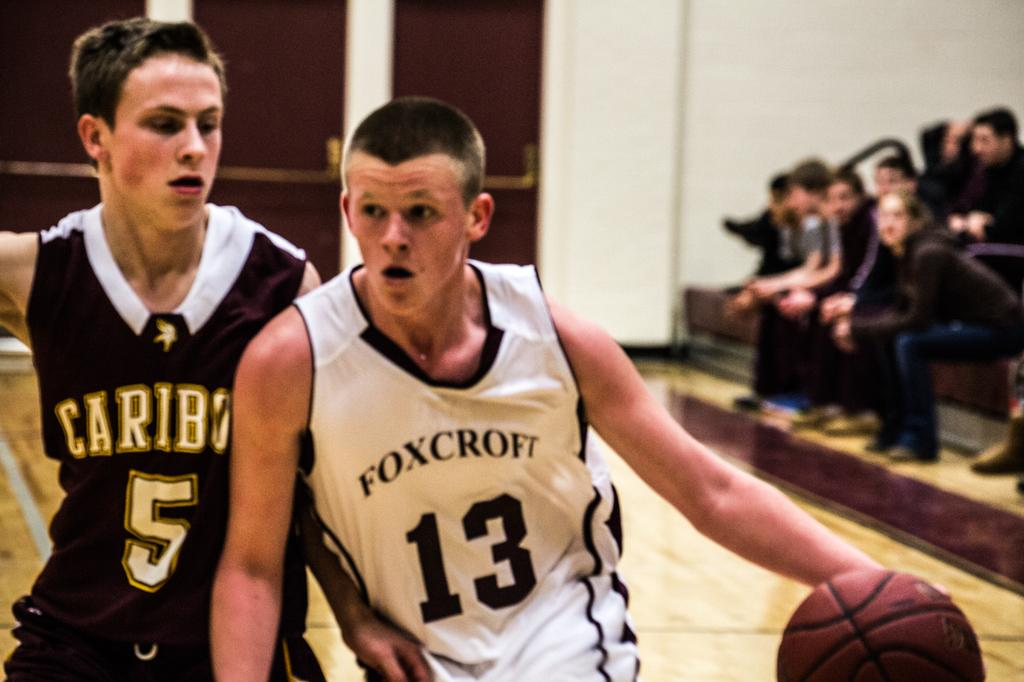<image>
Give a short and clear explanation of the subsequent image. A member of the Foxcroft basketball team cuts off an opposing player. 